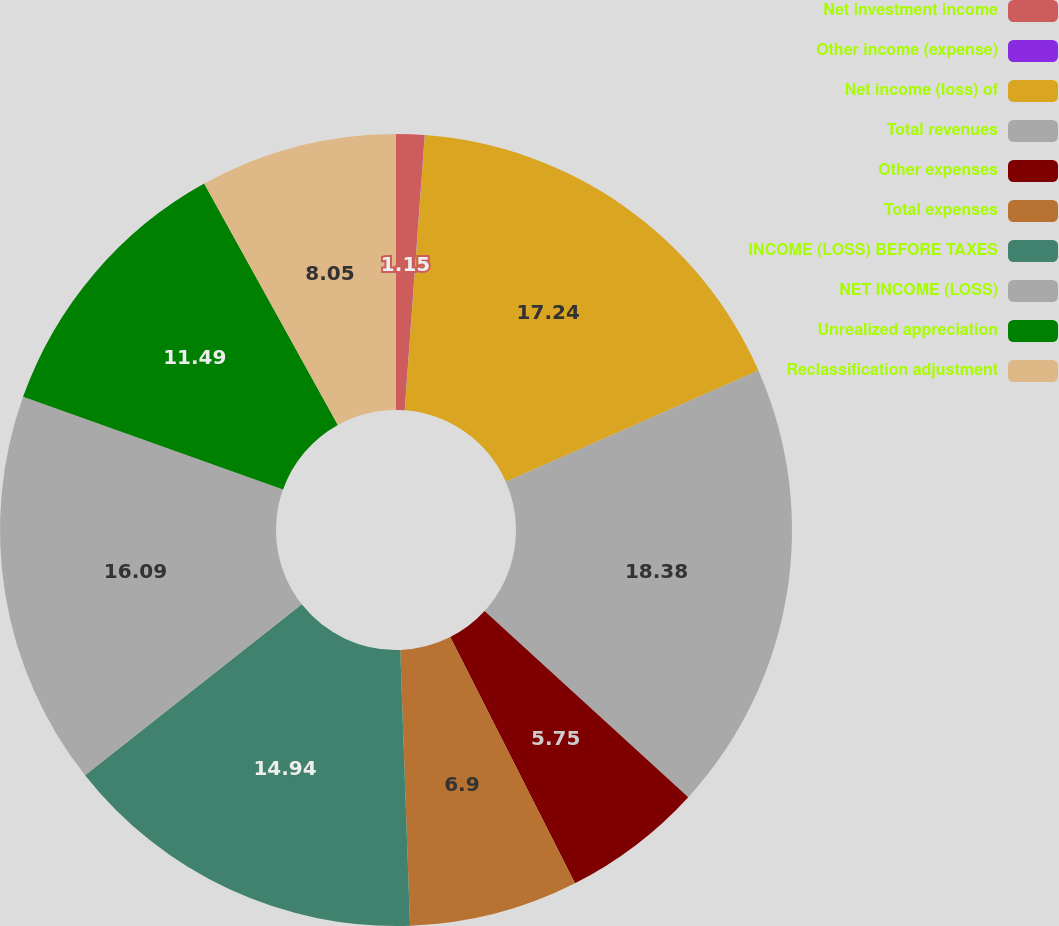<chart> <loc_0><loc_0><loc_500><loc_500><pie_chart><fcel>Net investment income<fcel>Other income (expense)<fcel>Net income (loss) of<fcel>Total revenues<fcel>Other expenses<fcel>Total expenses<fcel>INCOME (LOSS) BEFORE TAXES<fcel>NET INCOME (LOSS)<fcel>Unrealized appreciation<fcel>Reclassification adjustment<nl><fcel>1.15%<fcel>0.01%<fcel>17.24%<fcel>18.39%<fcel>5.75%<fcel>6.9%<fcel>14.94%<fcel>16.09%<fcel>11.49%<fcel>8.05%<nl></chart> 